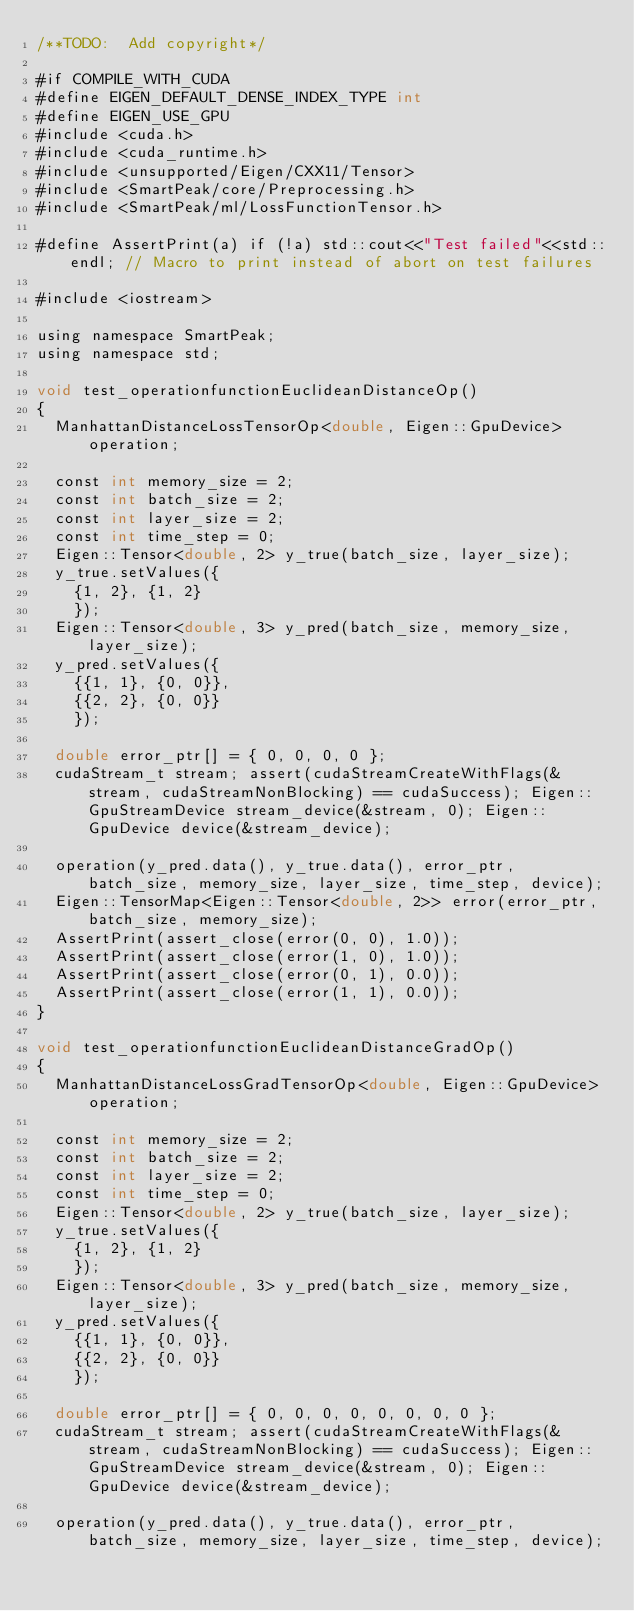<code> <loc_0><loc_0><loc_500><loc_500><_Cuda_>/**TODO:  Add copyright*/

#if COMPILE_WITH_CUDA
#define EIGEN_DEFAULT_DENSE_INDEX_TYPE int
#define EIGEN_USE_GPU
#include <cuda.h>
#include <cuda_runtime.h>
#include <unsupported/Eigen/CXX11/Tensor>
#include <SmartPeak/core/Preprocessing.h>
#include <SmartPeak/ml/LossFunctionTensor.h>

#define AssertPrint(a) if (!a) std::cout<<"Test failed"<<std::endl; // Macro to print instead of abort on test failures

#include <iostream>

using namespace SmartPeak;
using namespace std;

void test_operationfunctionEuclideanDistanceOp()
{
  ManhattanDistanceLossTensorOp<double, Eigen::GpuDevice> operation;

  const int memory_size = 2;
  const int batch_size = 2;
  const int layer_size = 2;
  const int time_step = 0;
  Eigen::Tensor<double, 2> y_true(batch_size, layer_size);
  y_true.setValues({
    {1, 2}, {1, 2}
    });
  Eigen::Tensor<double, 3> y_pred(batch_size, memory_size, layer_size);
  y_pred.setValues({
    {{1, 1}, {0, 0}},
    {{2, 2}, {0, 0}}
    });

  double error_ptr[] = { 0, 0, 0, 0 };
  cudaStream_t stream; assert(cudaStreamCreateWithFlags(&stream, cudaStreamNonBlocking) == cudaSuccess); Eigen::GpuStreamDevice stream_device(&stream, 0); Eigen::GpuDevice device(&stream_device);

  operation(y_pred.data(), y_true.data(), error_ptr, batch_size, memory_size, layer_size, time_step, device);
  Eigen::TensorMap<Eigen::Tensor<double, 2>> error(error_ptr, batch_size, memory_size);
  AssertPrint(assert_close(error(0, 0), 1.0));
  AssertPrint(assert_close(error(1, 0), 1.0));
  AssertPrint(assert_close(error(0, 1), 0.0));
  AssertPrint(assert_close(error(1, 1), 0.0));
}

void test_operationfunctionEuclideanDistanceGradOp()
{
  ManhattanDistanceLossGradTensorOp<double, Eigen::GpuDevice> operation;

  const int memory_size = 2;
  const int batch_size = 2;
  const int layer_size = 2;
  const int time_step = 0;
  Eigen::Tensor<double, 2> y_true(batch_size, layer_size);
  y_true.setValues({
    {1, 2}, {1, 2}
    });
  Eigen::Tensor<double, 3> y_pred(batch_size, memory_size, layer_size);
  y_pred.setValues({
    {{1, 1}, {0, 0}},
    {{2, 2}, {0, 0}}
    });

  double error_ptr[] = { 0, 0, 0, 0, 0, 0, 0, 0 };
  cudaStream_t stream; assert(cudaStreamCreateWithFlags(&stream, cudaStreamNonBlocking) == cudaSuccess); Eigen::GpuStreamDevice stream_device(&stream, 0); Eigen::GpuDevice device(&stream_device);

  operation(y_pred.data(), y_true.data(), error_ptr, batch_size, memory_size, layer_size, time_step, device);</code> 